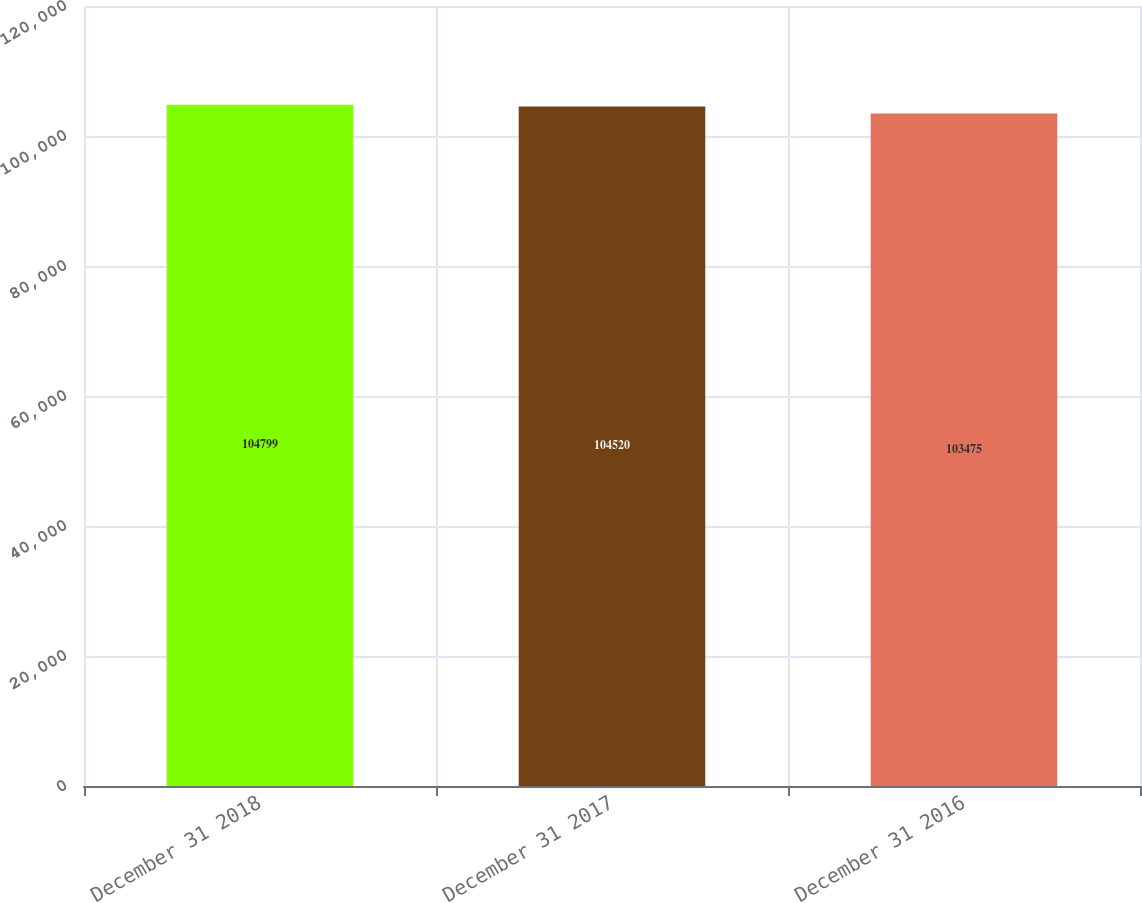<chart> <loc_0><loc_0><loc_500><loc_500><bar_chart><fcel>December 31 2018<fcel>December 31 2017<fcel>December 31 2016<nl><fcel>104799<fcel>104520<fcel>103475<nl></chart> 